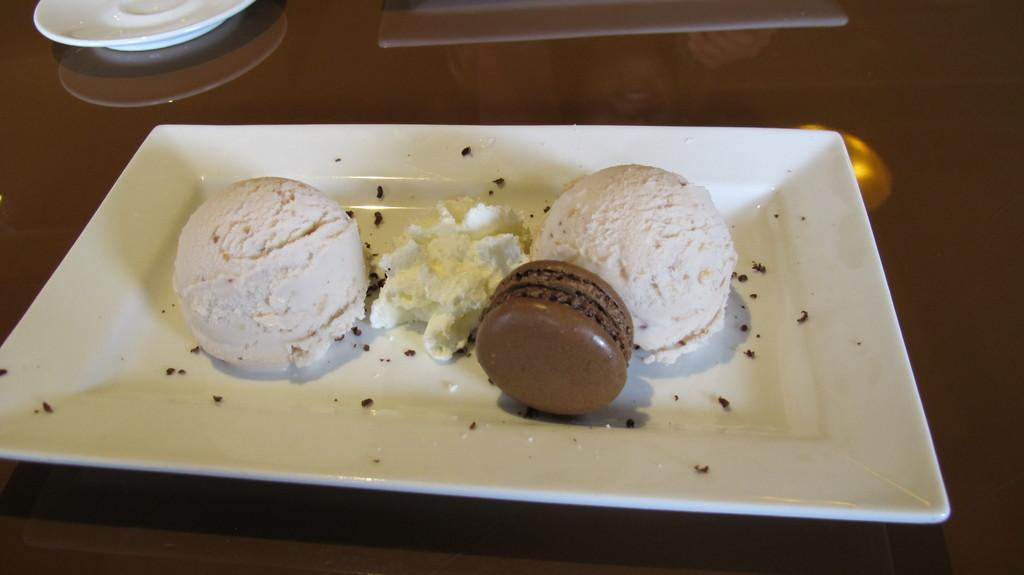What is present on the table in the image? There are ice cream scoops and other food items on a plate in the image. How many plates can be seen on the table? There are two plates on the table in the image. What is the purpose of the second plate on the table? The purpose of the second plate on the table is not specified in the image. What type of noise can be heard coming from the ice cream scoops in the image? There is no noise coming from the ice cream scoops in the image, as they are inanimate objects. 